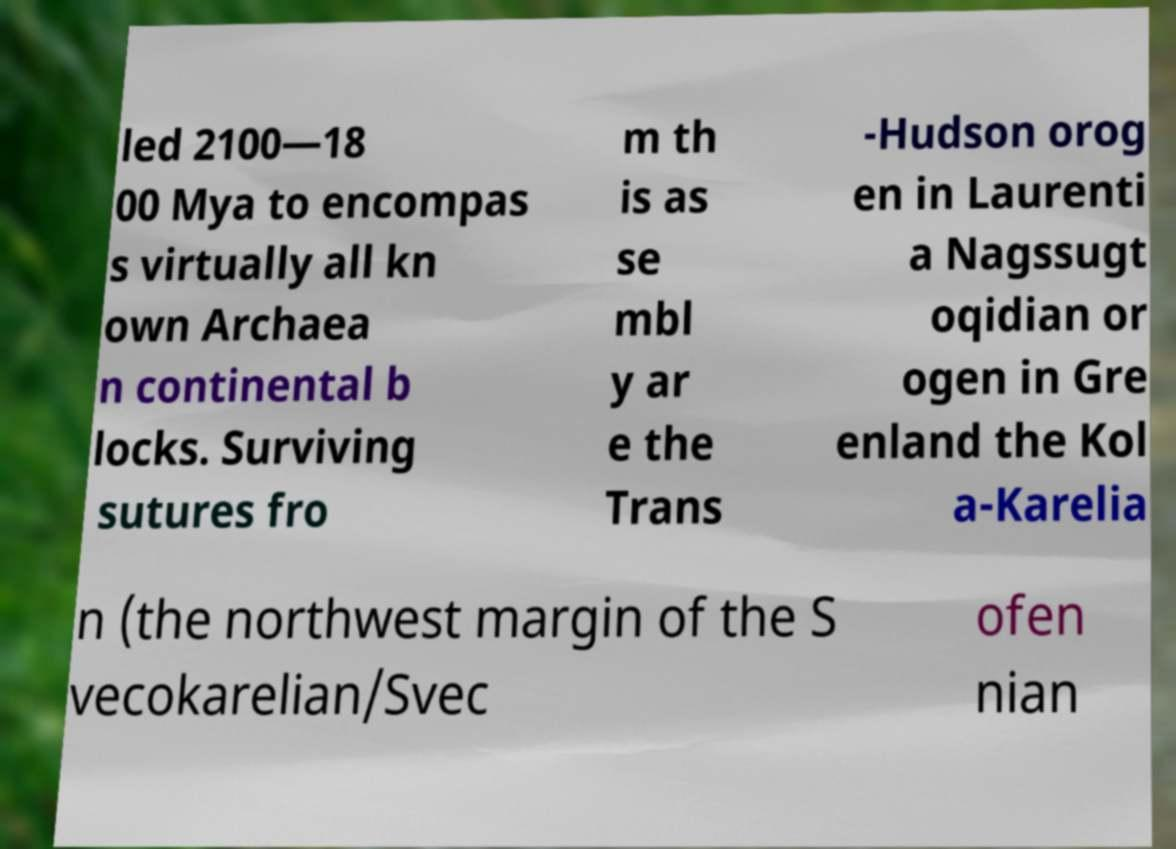Can you accurately transcribe the text from the provided image for me? led 2100—18 00 Mya to encompas s virtually all kn own Archaea n continental b locks. Surviving sutures fro m th is as se mbl y ar e the Trans -Hudson orog en in Laurenti a Nagssugt oqidian or ogen in Gre enland the Kol a-Karelia n (the northwest margin of the S vecokarelian/Svec ofen nian 